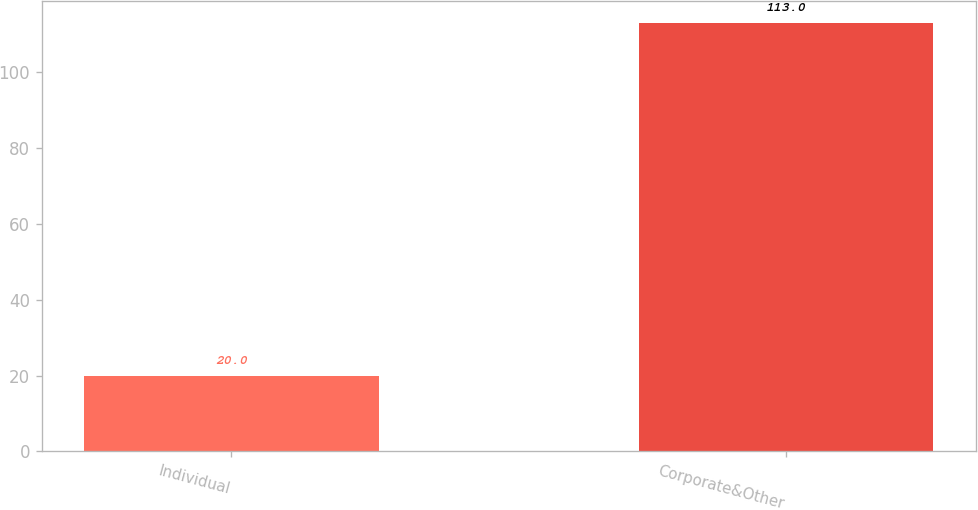Convert chart. <chart><loc_0><loc_0><loc_500><loc_500><bar_chart><fcel>Individual<fcel>Corporate&Other<nl><fcel>20<fcel>113<nl></chart> 